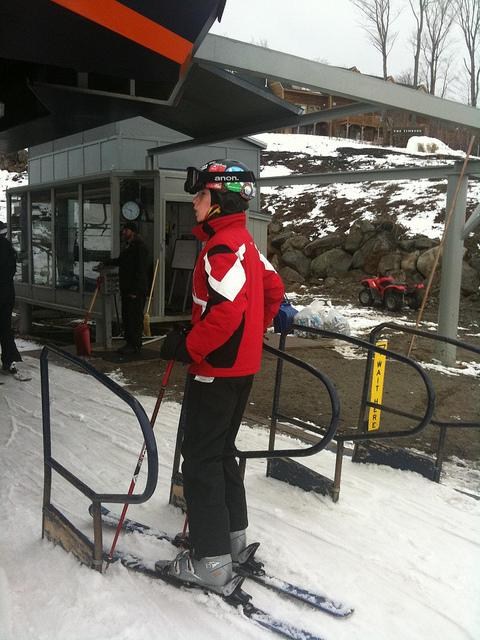What is the person in red most likely awaiting a turn for? chairlift 